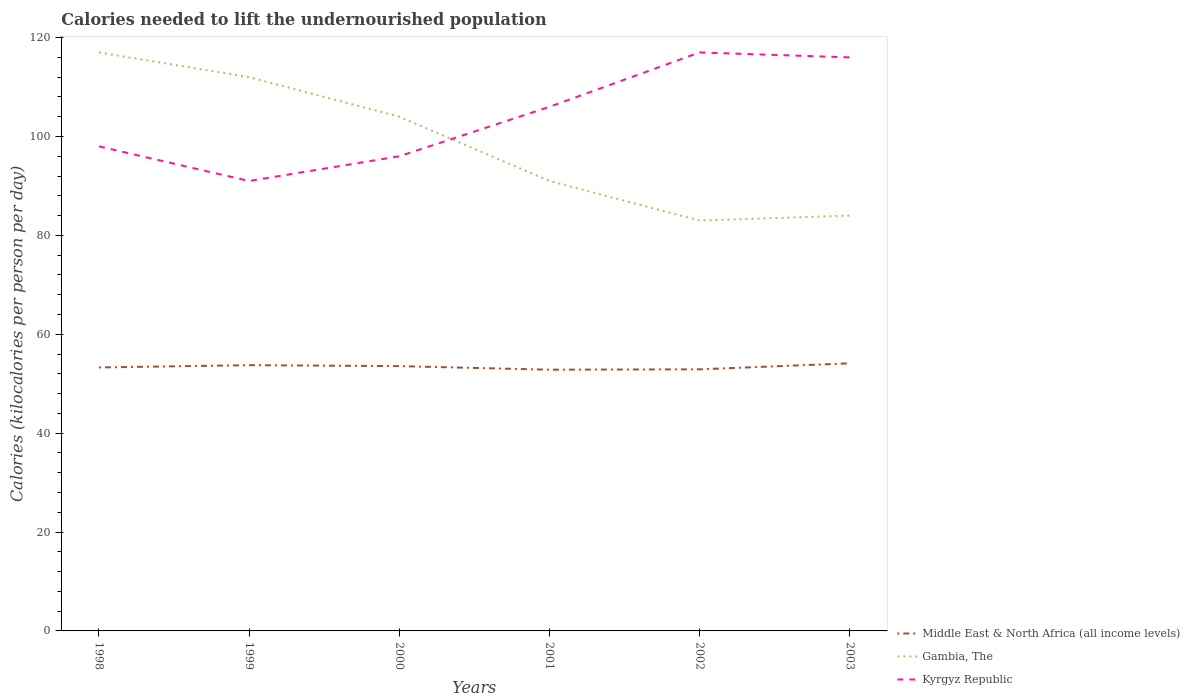Is the number of lines equal to the number of legend labels?
Your response must be concise. Yes. Across all years, what is the maximum total calories needed to lift the undernourished population in Kyrgyz Republic?
Provide a short and direct response. 91. In which year was the total calories needed to lift the undernourished population in Middle East & North Africa (all income levels) maximum?
Offer a terse response. 2001. What is the total total calories needed to lift the undernourished population in Gambia, The in the graph?
Offer a terse response. 21. What is the difference between the highest and the second highest total calories needed to lift the undernourished population in Kyrgyz Republic?
Ensure brevity in your answer.  26. Is the total calories needed to lift the undernourished population in Kyrgyz Republic strictly greater than the total calories needed to lift the undernourished population in Gambia, The over the years?
Give a very brief answer. No. How many lines are there?
Give a very brief answer. 3. How many years are there in the graph?
Give a very brief answer. 6. Does the graph contain any zero values?
Make the answer very short. No. What is the title of the graph?
Offer a very short reply. Calories needed to lift the undernourished population. Does "Denmark" appear as one of the legend labels in the graph?
Provide a short and direct response. No. What is the label or title of the X-axis?
Provide a short and direct response. Years. What is the label or title of the Y-axis?
Your response must be concise. Calories (kilocalories per person per day). What is the Calories (kilocalories per person per day) in Middle East & North Africa (all income levels) in 1998?
Give a very brief answer. 53.29. What is the Calories (kilocalories per person per day) in Gambia, The in 1998?
Keep it short and to the point. 117. What is the Calories (kilocalories per person per day) in Kyrgyz Republic in 1998?
Offer a terse response. 98. What is the Calories (kilocalories per person per day) in Middle East & North Africa (all income levels) in 1999?
Provide a succinct answer. 53.75. What is the Calories (kilocalories per person per day) in Gambia, The in 1999?
Your answer should be compact. 112. What is the Calories (kilocalories per person per day) of Kyrgyz Republic in 1999?
Your answer should be very brief. 91. What is the Calories (kilocalories per person per day) of Middle East & North Africa (all income levels) in 2000?
Offer a very short reply. 53.56. What is the Calories (kilocalories per person per day) in Gambia, The in 2000?
Your answer should be very brief. 104. What is the Calories (kilocalories per person per day) of Kyrgyz Republic in 2000?
Your answer should be compact. 96. What is the Calories (kilocalories per person per day) of Middle East & North Africa (all income levels) in 2001?
Make the answer very short. 52.83. What is the Calories (kilocalories per person per day) of Gambia, The in 2001?
Offer a terse response. 91. What is the Calories (kilocalories per person per day) of Kyrgyz Republic in 2001?
Make the answer very short. 106. What is the Calories (kilocalories per person per day) in Middle East & North Africa (all income levels) in 2002?
Your answer should be compact. 52.91. What is the Calories (kilocalories per person per day) of Gambia, The in 2002?
Offer a terse response. 83. What is the Calories (kilocalories per person per day) in Kyrgyz Republic in 2002?
Your answer should be compact. 117. What is the Calories (kilocalories per person per day) of Middle East & North Africa (all income levels) in 2003?
Offer a terse response. 54.12. What is the Calories (kilocalories per person per day) of Gambia, The in 2003?
Your answer should be compact. 84. What is the Calories (kilocalories per person per day) in Kyrgyz Republic in 2003?
Offer a very short reply. 116. Across all years, what is the maximum Calories (kilocalories per person per day) in Middle East & North Africa (all income levels)?
Offer a very short reply. 54.12. Across all years, what is the maximum Calories (kilocalories per person per day) in Gambia, The?
Provide a succinct answer. 117. Across all years, what is the maximum Calories (kilocalories per person per day) in Kyrgyz Republic?
Keep it short and to the point. 117. Across all years, what is the minimum Calories (kilocalories per person per day) in Middle East & North Africa (all income levels)?
Your response must be concise. 52.83. Across all years, what is the minimum Calories (kilocalories per person per day) of Kyrgyz Republic?
Offer a terse response. 91. What is the total Calories (kilocalories per person per day) of Middle East & North Africa (all income levels) in the graph?
Provide a short and direct response. 320.46. What is the total Calories (kilocalories per person per day) in Gambia, The in the graph?
Offer a very short reply. 591. What is the total Calories (kilocalories per person per day) of Kyrgyz Republic in the graph?
Keep it short and to the point. 624. What is the difference between the Calories (kilocalories per person per day) in Middle East & North Africa (all income levels) in 1998 and that in 1999?
Keep it short and to the point. -0.46. What is the difference between the Calories (kilocalories per person per day) of Gambia, The in 1998 and that in 1999?
Your response must be concise. 5. What is the difference between the Calories (kilocalories per person per day) in Kyrgyz Republic in 1998 and that in 1999?
Offer a very short reply. 7. What is the difference between the Calories (kilocalories per person per day) of Middle East & North Africa (all income levels) in 1998 and that in 2000?
Make the answer very short. -0.27. What is the difference between the Calories (kilocalories per person per day) of Gambia, The in 1998 and that in 2000?
Provide a short and direct response. 13. What is the difference between the Calories (kilocalories per person per day) of Middle East & North Africa (all income levels) in 1998 and that in 2001?
Your response must be concise. 0.45. What is the difference between the Calories (kilocalories per person per day) in Gambia, The in 1998 and that in 2001?
Ensure brevity in your answer.  26. What is the difference between the Calories (kilocalories per person per day) of Middle East & North Africa (all income levels) in 1998 and that in 2002?
Your answer should be compact. 0.38. What is the difference between the Calories (kilocalories per person per day) of Gambia, The in 1998 and that in 2002?
Offer a terse response. 34. What is the difference between the Calories (kilocalories per person per day) of Middle East & North Africa (all income levels) in 1998 and that in 2003?
Make the answer very short. -0.84. What is the difference between the Calories (kilocalories per person per day) in Middle East & North Africa (all income levels) in 1999 and that in 2000?
Offer a terse response. 0.19. What is the difference between the Calories (kilocalories per person per day) in Middle East & North Africa (all income levels) in 1999 and that in 2001?
Your answer should be very brief. 0.92. What is the difference between the Calories (kilocalories per person per day) in Kyrgyz Republic in 1999 and that in 2001?
Ensure brevity in your answer.  -15. What is the difference between the Calories (kilocalories per person per day) in Middle East & North Africa (all income levels) in 1999 and that in 2002?
Provide a succinct answer. 0.84. What is the difference between the Calories (kilocalories per person per day) in Middle East & North Africa (all income levels) in 1999 and that in 2003?
Provide a short and direct response. -0.37. What is the difference between the Calories (kilocalories per person per day) in Middle East & North Africa (all income levels) in 2000 and that in 2001?
Offer a very short reply. 0.72. What is the difference between the Calories (kilocalories per person per day) in Kyrgyz Republic in 2000 and that in 2001?
Give a very brief answer. -10. What is the difference between the Calories (kilocalories per person per day) in Middle East & North Africa (all income levels) in 2000 and that in 2002?
Your response must be concise. 0.65. What is the difference between the Calories (kilocalories per person per day) of Kyrgyz Republic in 2000 and that in 2002?
Make the answer very short. -21. What is the difference between the Calories (kilocalories per person per day) of Middle East & North Africa (all income levels) in 2000 and that in 2003?
Offer a very short reply. -0.57. What is the difference between the Calories (kilocalories per person per day) in Middle East & North Africa (all income levels) in 2001 and that in 2002?
Your response must be concise. -0.08. What is the difference between the Calories (kilocalories per person per day) in Gambia, The in 2001 and that in 2002?
Your response must be concise. 8. What is the difference between the Calories (kilocalories per person per day) in Kyrgyz Republic in 2001 and that in 2002?
Provide a succinct answer. -11. What is the difference between the Calories (kilocalories per person per day) in Middle East & North Africa (all income levels) in 2001 and that in 2003?
Your response must be concise. -1.29. What is the difference between the Calories (kilocalories per person per day) of Kyrgyz Republic in 2001 and that in 2003?
Offer a terse response. -10. What is the difference between the Calories (kilocalories per person per day) in Middle East & North Africa (all income levels) in 2002 and that in 2003?
Your answer should be very brief. -1.21. What is the difference between the Calories (kilocalories per person per day) in Gambia, The in 2002 and that in 2003?
Make the answer very short. -1. What is the difference between the Calories (kilocalories per person per day) of Middle East & North Africa (all income levels) in 1998 and the Calories (kilocalories per person per day) of Gambia, The in 1999?
Your answer should be compact. -58.71. What is the difference between the Calories (kilocalories per person per day) of Middle East & North Africa (all income levels) in 1998 and the Calories (kilocalories per person per day) of Kyrgyz Republic in 1999?
Make the answer very short. -37.71. What is the difference between the Calories (kilocalories per person per day) of Middle East & North Africa (all income levels) in 1998 and the Calories (kilocalories per person per day) of Gambia, The in 2000?
Ensure brevity in your answer.  -50.71. What is the difference between the Calories (kilocalories per person per day) of Middle East & North Africa (all income levels) in 1998 and the Calories (kilocalories per person per day) of Kyrgyz Republic in 2000?
Keep it short and to the point. -42.71. What is the difference between the Calories (kilocalories per person per day) of Middle East & North Africa (all income levels) in 1998 and the Calories (kilocalories per person per day) of Gambia, The in 2001?
Your response must be concise. -37.71. What is the difference between the Calories (kilocalories per person per day) in Middle East & North Africa (all income levels) in 1998 and the Calories (kilocalories per person per day) in Kyrgyz Republic in 2001?
Keep it short and to the point. -52.71. What is the difference between the Calories (kilocalories per person per day) in Middle East & North Africa (all income levels) in 1998 and the Calories (kilocalories per person per day) in Gambia, The in 2002?
Give a very brief answer. -29.71. What is the difference between the Calories (kilocalories per person per day) of Middle East & North Africa (all income levels) in 1998 and the Calories (kilocalories per person per day) of Kyrgyz Republic in 2002?
Make the answer very short. -63.71. What is the difference between the Calories (kilocalories per person per day) of Gambia, The in 1998 and the Calories (kilocalories per person per day) of Kyrgyz Republic in 2002?
Your response must be concise. 0. What is the difference between the Calories (kilocalories per person per day) of Middle East & North Africa (all income levels) in 1998 and the Calories (kilocalories per person per day) of Gambia, The in 2003?
Ensure brevity in your answer.  -30.71. What is the difference between the Calories (kilocalories per person per day) in Middle East & North Africa (all income levels) in 1998 and the Calories (kilocalories per person per day) in Kyrgyz Republic in 2003?
Provide a short and direct response. -62.71. What is the difference between the Calories (kilocalories per person per day) of Middle East & North Africa (all income levels) in 1999 and the Calories (kilocalories per person per day) of Gambia, The in 2000?
Provide a short and direct response. -50.25. What is the difference between the Calories (kilocalories per person per day) in Middle East & North Africa (all income levels) in 1999 and the Calories (kilocalories per person per day) in Kyrgyz Republic in 2000?
Your answer should be compact. -42.25. What is the difference between the Calories (kilocalories per person per day) in Gambia, The in 1999 and the Calories (kilocalories per person per day) in Kyrgyz Republic in 2000?
Provide a short and direct response. 16. What is the difference between the Calories (kilocalories per person per day) of Middle East & North Africa (all income levels) in 1999 and the Calories (kilocalories per person per day) of Gambia, The in 2001?
Offer a terse response. -37.25. What is the difference between the Calories (kilocalories per person per day) in Middle East & North Africa (all income levels) in 1999 and the Calories (kilocalories per person per day) in Kyrgyz Republic in 2001?
Provide a short and direct response. -52.25. What is the difference between the Calories (kilocalories per person per day) in Gambia, The in 1999 and the Calories (kilocalories per person per day) in Kyrgyz Republic in 2001?
Offer a terse response. 6. What is the difference between the Calories (kilocalories per person per day) of Middle East & North Africa (all income levels) in 1999 and the Calories (kilocalories per person per day) of Gambia, The in 2002?
Your answer should be very brief. -29.25. What is the difference between the Calories (kilocalories per person per day) in Middle East & North Africa (all income levels) in 1999 and the Calories (kilocalories per person per day) in Kyrgyz Republic in 2002?
Give a very brief answer. -63.25. What is the difference between the Calories (kilocalories per person per day) in Gambia, The in 1999 and the Calories (kilocalories per person per day) in Kyrgyz Republic in 2002?
Ensure brevity in your answer.  -5. What is the difference between the Calories (kilocalories per person per day) in Middle East & North Africa (all income levels) in 1999 and the Calories (kilocalories per person per day) in Gambia, The in 2003?
Ensure brevity in your answer.  -30.25. What is the difference between the Calories (kilocalories per person per day) of Middle East & North Africa (all income levels) in 1999 and the Calories (kilocalories per person per day) of Kyrgyz Republic in 2003?
Ensure brevity in your answer.  -62.25. What is the difference between the Calories (kilocalories per person per day) in Gambia, The in 1999 and the Calories (kilocalories per person per day) in Kyrgyz Republic in 2003?
Your answer should be compact. -4. What is the difference between the Calories (kilocalories per person per day) of Middle East & North Africa (all income levels) in 2000 and the Calories (kilocalories per person per day) of Gambia, The in 2001?
Provide a succinct answer. -37.44. What is the difference between the Calories (kilocalories per person per day) of Middle East & North Africa (all income levels) in 2000 and the Calories (kilocalories per person per day) of Kyrgyz Republic in 2001?
Offer a very short reply. -52.44. What is the difference between the Calories (kilocalories per person per day) in Middle East & North Africa (all income levels) in 2000 and the Calories (kilocalories per person per day) in Gambia, The in 2002?
Your answer should be very brief. -29.44. What is the difference between the Calories (kilocalories per person per day) of Middle East & North Africa (all income levels) in 2000 and the Calories (kilocalories per person per day) of Kyrgyz Republic in 2002?
Your answer should be compact. -63.44. What is the difference between the Calories (kilocalories per person per day) in Middle East & North Africa (all income levels) in 2000 and the Calories (kilocalories per person per day) in Gambia, The in 2003?
Keep it short and to the point. -30.44. What is the difference between the Calories (kilocalories per person per day) of Middle East & North Africa (all income levels) in 2000 and the Calories (kilocalories per person per day) of Kyrgyz Republic in 2003?
Your response must be concise. -62.44. What is the difference between the Calories (kilocalories per person per day) of Gambia, The in 2000 and the Calories (kilocalories per person per day) of Kyrgyz Republic in 2003?
Make the answer very short. -12. What is the difference between the Calories (kilocalories per person per day) of Middle East & North Africa (all income levels) in 2001 and the Calories (kilocalories per person per day) of Gambia, The in 2002?
Provide a short and direct response. -30.17. What is the difference between the Calories (kilocalories per person per day) of Middle East & North Africa (all income levels) in 2001 and the Calories (kilocalories per person per day) of Kyrgyz Republic in 2002?
Give a very brief answer. -64.17. What is the difference between the Calories (kilocalories per person per day) in Middle East & North Africa (all income levels) in 2001 and the Calories (kilocalories per person per day) in Gambia, The in 2003?
Make the answer very short. -31.17. What is the difference between the Calories (kilocalories per person per day) in Middle East & North Africa (all income levels) in 2001 and the Calories (kilocalories per person per day) in Kyrgyz Republic in 2003?
Give a very brief answer. -63.17. What is the difference between the Calories (kilocalories per person per day) of Gambia, The in 2001 and the Calories (kilocalories per person per day) of Kyrgyz Republic in 2003?
Ensure brevity in your answer.  -25. What is the difference between the Calories (kilocalories per person per day) in Middle East & North Africa (all income levels) in 2002 and the Calories (kilocalories per person per day) in Gambia, The in 2003?
Ensure brevity in your answer.  -31.09. What is the difference between the Calories (kilocalories per person per day) in Middle East & North Africa (all income levels) in 2002 and the Calories (kilocalories per person per day) in Kyrgyz Republic in 2003?
Ensure brevity in your answer.  -63.09. What is the difference between the Calories (kilocalories per person per day) in Gambia, The in 2002 and the Calories (kilocalories per person per day) in Kyrgyz Republic in 2003?
Keep it short and to the point. -33. What is the average Calories (kilocalories per person per day) of Middle East & North Africa (all income levels) per year?
Your answer should be very brief. 53.41. What is the average Calories (kilocalories per person per day) in Gambia, The per year?
Give a very brief answer. 98.5. What is the average Calories (kilocalories per person per day) of Kyrgyz Republic per year?
Your response must be concise. 104. In the year 1998, what is the difference between the Calories (kilocalories per person per day) of Middle East & North Africa (all income levels) and Calories (kilocalories per person per day) of Gambia, The?
Give a very brief answer. -63.71. In the year 1998, what is the difference between the Calories (kilocalories per person per day) of Middle East & North Africa (all income levels) and Calories (kilocalories per person per day) of Kyrgyz Republic?
Your answer should be compact. -44.71. In the year 1998, what is the difference between the Calories (kilocalories per person per day) of Gambia, The and Calories (kilocalories per person per day) of Kyrgyz Republic?
Provide a short and direct response. 19. In the year 1999, what is the difference between the Calories (kilocalories per person per day) in Middle East & North Africa (all income levels) and Calories (kilocalories per person per day) in Gambia, The?
Offer a very short reply. -58.25. In the year 1999, what is the difference between the Calories (kilocalories per person per day) of Middle East & North Africa (all income levels) and Calories (kilocalories per person per day) of Kyrgyz Republic?
Provide a succinct answer. -37.25. In the year 2000, what is the difference between the Calories (kilocalories per person per day) in Middle East & North Africa (all income levels) and Calories (kilocalories per person per day) in Gambia, The?
Your answer should be compact. -50.44. In the year 2000, what is the difference between the Calories (kilocalories per person per day) of Middle East & North Africa (all income levels) and Calories (kilocalories per person per day) of Kyrgyz Republic?
Keep it short and to the point. -42.44. In the year 2000, what is the difference between the Calories (kilocalories per person per day) of Gambia, The and Calories (kilocalories per person per day) of Kyrgyz Republic?
Keep it short and to the point. 8. In the year 2001, what is the difference between the Calories (kilocalories per person per day) of Middle East & North Africa (all income levels) and Calories (kilocalories per person per day) of Gambia, The?
Your answer should be very brief. -38.17. In the year 2001, what is the difference between the Calories (kilocalories per person per day) of Middle East & North Africa (all income levels) and Calories (kilocalories per person per day) of Kyrgyz Republic?
Make the answer very short. -53.17. In the year 2002, what is the difference between the Calories (kilocalories per person per day) in Middle East & North Africa (all income levels) and Calories (kilocalories per person per day) in Gambia, The?
Your answer should be compact. -30.09. In the year 2002, what is the difference between the Calories (kilocalories per person per day) of Middle East & North Africa (all income levels) and Calories (kilocalories per person per day) of Kyrgyz Republic?
Provide a short and direct response. -64.09. In the year 2002, what is the difference between the Calories (kilocalories per person per day) of Gambia, The and Calories (kilocalories per person per day) of Kyrgyz Republic?
Give a very brief answer. -34. In the year 2003, what is the difference between the Calories (kilocalories per person per day) of Middle East & North Africa (all income levels) and Calories (kilocalories per person per day) of Gambia, The?
Offer a terse response. -29.88. In the year 2003, what is the difference between the Calories (kilocalories per person per day) of Middle East & North Africa (all income levels) and Calories (kilocalories per person per day) of Kyrgyz Republic?
Keep it short and to the point. -61.88. In the year 2003, what is the difference between the Calories (kilocalories per person per day) in Gambia, The and Calories (kilocalories per person per day) in Kyrgyz Republic?
Keep it short and to the point. -32. What is the ratio of the Calories (kilocalories per person per day) in Gambia, The in 1998 to that in 1999?
Give a very brief answer. 1.04. What is the ratio of the Calories (kilocalories per person per day) in Kyrgyz Republic in 1998 to that in 1999?
Your response must be concise. 1.08. What is the ratio of the Calories (kilocalories per person per day) of Kyrgyz Republic in 1998 to that in 2000?
Your answer should be very brief. 1.02. What is the ratio of the Calories (kilocalories per person per day) in Middle East & North Africa (all income levels) in 1998 to that in 2001?
Offer a very short reply. 1.01. What is the ratio of the Calories (kilocalories per person per day) in Kyrgyz Republic in 1998 to that in 2001?
Keep it short and to the point. 0.92. What is the ratio of the Calories (kilocalories per person per day) in Middle East & North Africa (all income levels) in 1998 to that in 2002?
Your answer should be compact. 1.01. What is the ratio of the Calories (kilocalories per person per day) in Gambia, The in 1998 to that in 2002?
Your answer should be compact. 1.41. What is the ratio of the Calories (kilocalories per person per day) in Kyrgyz Republic in 1998 to that in 2002?
Provide a succinct answer. 0.84. What is the ratio of the Calories (kilocalories per person per day) of Middle East & North Africa (all income levels) in 1998 to that in 2003?
Provide a succinct answer. 0.98. What is the ratio of the Calories (kilocalories per person per day) of Gambia, The in 1998 to that in 2003?
Your answer should be compact. 1.39. What is the ratio of the Calories (kilocalories per person per day) in Kyrgyz Republic in 1998 to that in 2003?
Make the answer very short. 0.84. What is the ratio of the Calories (kilocalories per person per day) of Middle East & North Africa (all income levels) in 1999 to that in 2000?
Keep it short and to the point. 1. What is the ratio of the Calories (kilocalories per person per day) of Kyrgyz Republic in 1999 to that in 2000?
Give a very brief answer. 0.95. What is the ratio of the Calories (kilocalories per person per day) of Middle East & North Africa (all income levels) in 1999 to that in 2001?
Offer a terse response. 1.02. What is the ratio of the Calories (kilocalories per person per day) of Gambia, The in 1999 to that in 2001?
Offer a terse response. 1.23. What is the ratio of the Calories (kilocalories per person per day) in Kyrgyz Republic in 1999 to that in 2001?
Provide a short and direct response. 0.86. What is the ratio of the Calories (kilocalories per person per day) in Middle East & North Africa (all income levels) in 1999 to that in 2002?
Ensure brevity in your answer.  1.02. What is the ratio of the Calories (kilocalories per person per day) of Gambia, The in 1999 to that in 2002?
Offer a terse response. 1.35. What is the ratio of the Calories (kilocalories per person per day) of Gambia, The in 1999 to that in 2003?
Provide a succinct answer. 1.33. What is the ratio of the Calories (kilocalories per person per day) in Kyrgyz Republic in 1999 to that in 2003?
Your answer should be compact. 0.78. What is the ratio of the Calories (kilocalories per person per day) of Middle East & North Africa (all income levels) in 2000 to that in 2001?
Your answer should be very brief. 1.01. What is the ratio of the Calories (kilocalories per person per day) in Kyrgyz Republic in 2000 to that in 2001?
Make the answer very short. 0.91. What is the ratio of the Calories (kilocalories per person per day) of Middle East & North Africa (all income levels) in 2000 to that in 2002?
Your response must be concise. 1.01. What is the ratio of the Calories (kilocalories per person per day) of Gambia, The in 2000 to that in 2002?
Your answer should be very brief. 1.25. What is the ratio of the Calories (kilocalories per person per day) in Kyrgyz Republic in 2000 to that in 2002?
Offer a very short reply. 0.82. What is the ratio of the Calories (kilocalories per person per day) in Middle East & North Africa (all income levels) in 2000 to that in 2003?
Make the answer very short. 0.99. What is the ratio of the Calories (kilocalories per person per day) in Gambia, The in 2000 to that in 2003?
Your response must be concise. 1.24. What is the ratio of the Calories (kilocalories per person per day) of Kyrgyz Republic in 2000 to that in 2003?
Make the answer very short. 0.83. What is the ratio of the Calories (kilocalories per person per day) in Middle East & North Africa (all income levels) in 2001 to that in 2002?
Provide a short and direct response. 1. What is the ratio of the Calories (kilocalories per person per day) in Gambia, The in 2001 to that in 2002?
Keep it short and to the point. 1.1. What is the ratio of the Calories (kilocalories per person per day) of Kyrgyz Republic in 2001 to that in 2002?
Offer a terse response. 0.91. What is the ratio of the Calories (kilocalories per person per day) in Middle East & North Africa (all income levels) in 2001 to that in 2003?
Make the answer very short. 0.98. What is the ratio of the Calories (kilocalories per person per day) in Gambia, The in 2001 to that in 2003?
Offer a very short reply. 1.08. What is the ratio of the Calories (kilocalories per person per day) of Kyrgyz Republic in 2001 to that in 2003?
Your answer should be very brief. 0.91. What is the ratio of the Calories (kilocalories per person per day) in Middle East & North Africa (all income levels) in 2002 to that in 2003?
Offer a terse response. 0.98. What is the ratio of the Calories (kilocalories per person per day) of Gambia, The in 2002 to that in 2003?
Make the answer very short. 0.99. What is the ratio of the Calories (kilocalories per person per day) in Kyrgyz Republic in 2002 to that in 2003?
Ensure brevity in your answer.  1.01. What is the difference between the highest and the second highest Calories (kilocalories per person per day) of Middle East & North Africa (all income levels)?
Your response must be concise. 0.37. What is the difference between the highest and the lowest Calories (kilocalories per person per day) in Middle East & North Africa (all income levels)?
Make the answer very short. 1.29. What is the difference between the highest and the lowest Calories (kilocalories per person per day) in Kyrgyz Republic?
Give a very brief answer. 26. 